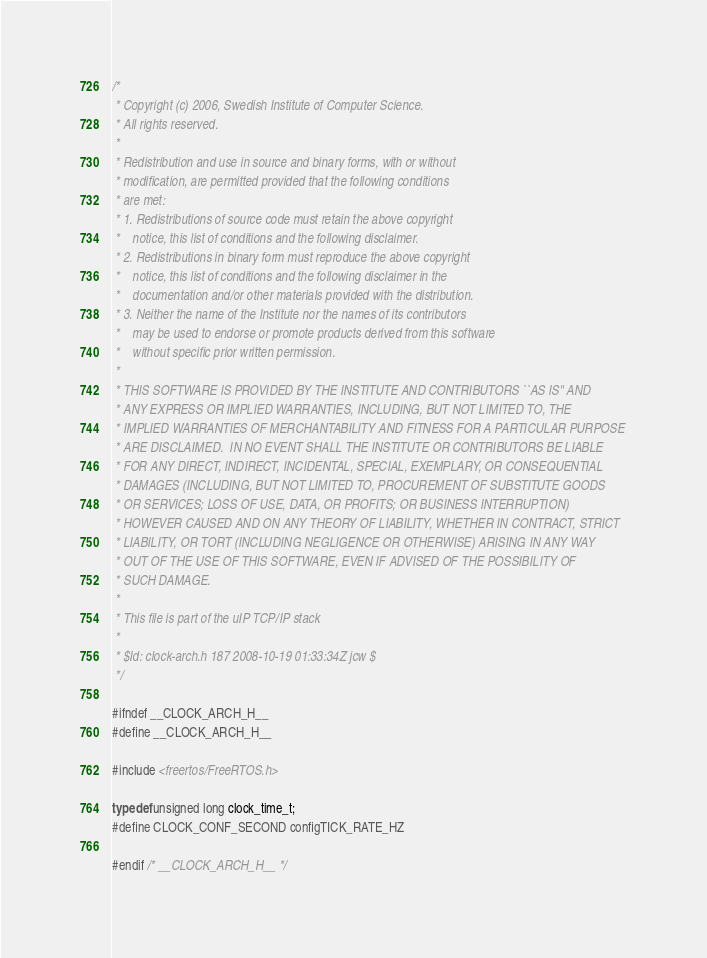<code> <loc_0><loc_0><loc_500><loc_500><_C_>/*
 * Copyright (c) 2006, Swedish Institute of Computer Science.
 * All rights reserved.
 *
 * Redistribution and use in source and binary forms, with or without
 * modification, are permitted provided that the following conditions
 * are met:
 * 1. Redistributions of source code must retain the above copyright
 *    notice, this list of conditions and the following disclaimer.
 * 2. Redistributions in binary form must reproduce the above copyright
 *    notice, this list of conditions and the following disclaimer in the
 *    documentation and/or other materials provided with the distribution.
 * 3. Neither the name of the Institute nor the names of its contributors
 *    may be used to endorse or promote products derived from this software
 *    without specific prior written permission.
 *
 * THIS SOFTWARE IS PROVIDED BY THE INSTITUTE AND CONTRIBUTORS ``AS IS'' AND
 * ANY EXPRESS OR IMPLIED WARRANTIES, INCLUDING, BUT NOT LIMITED TO, THE
 * IMPLIED WARRANTIES OF MERCHANTABILITY AND FITNESS FOR A PARTICULAR PURPOSE
 * ARE DISCLAIMED.  IN NO EVENT SHALL THE INSTITUTE OR CONTRIBUTORS BE LIABLE
 * FOR ANY DIRECT, INDIRECT, INCIDENTAL, SPECIAL, EXEMPLARY, OR CONSEQUENTIAL
 * DAMAGES (INCLUDING, BUT NOT LIMITED TO, PROCUREMENT OF SUBSTITUTE GOODS
 * OR SERVICES; LOSS OF USE, DATA, OR PROFITS; OR BUSINESS INTERRUPTION)
 * HOWEVER CAUSED AND ON ANY THEORY OF LIABILITY, WHETHER IN CONTRACT, STRICT
 * LIABILITY, OR TORT (INCLUDING NEGLIGENCE OR OTHERWISE) ARISING IN ANY WAY
 * OUT OF THE USE OF THIS SOFTWARE, EVEN IF ADVISED OF THE POSSIBILITY OF
 * SUCH DAMAGE.
 *
 * This file is part of the uIP TCP/IP stack
 *
 * $Id: clock-arch.h 187 2008-10-19 01:33:34Z jcw $
 */

#ifndef __CLOCK_ARCH_H__
#define __CLOCK_ARCH_H__

#include <freertos/FreeRTOS.h>

typedef unsigned long clock_time_t;
#define CLOCK_CONF_SECOND configTICK_RATE_HZ

#endif /* __CLOCK_ARCH_H__ */
</code> 